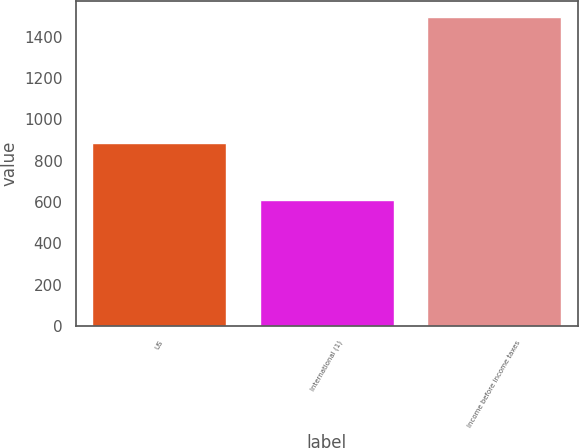Convert chart. <chart><loc_0><loc_0><loc_500><loc_500><bar_chart><fcel>US<fcel>International (1)<fcel>Income before income taxes<nl><fcel>886<fcel>611<fcel>1497<nl></chart> 